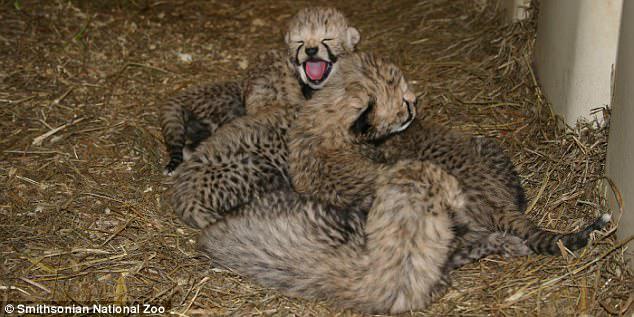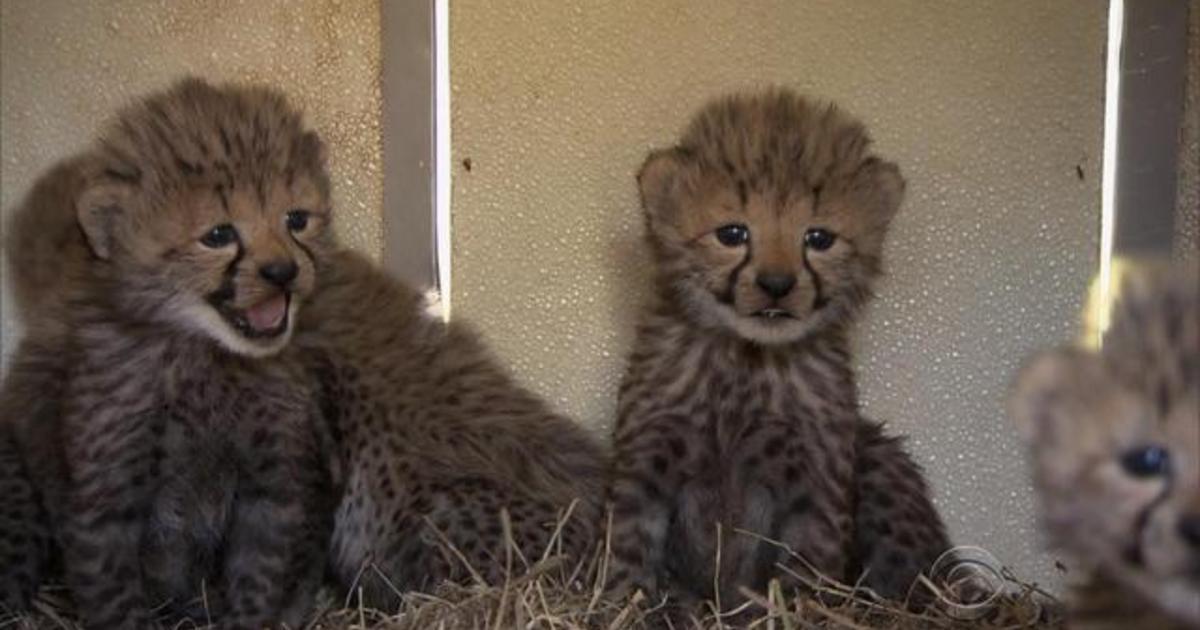The first image is the image on the left, the second image is the image on the right. For the images shown, is this caption "All of the animals shown are spotted wild kittens, and one image shows a group of wild kittens without fully open eyes in a pile on straw." true? Answer yes or no. Yes. The first image is the image on the left, the second image is the image on the right. Given the left and right images, does the statement "In the image to the left, we see three kittens; the young of big cat breeds." hold true? Answer yes or no. No. 